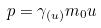<formula> <loc_0><loc_0><loc_500><loc_500>p = \gamma _ { ( u ) } m _ { 0 } u</formula> 